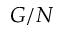<formula> <loc_0><loc_0><loc_500><loc_500>G / N</formula> 